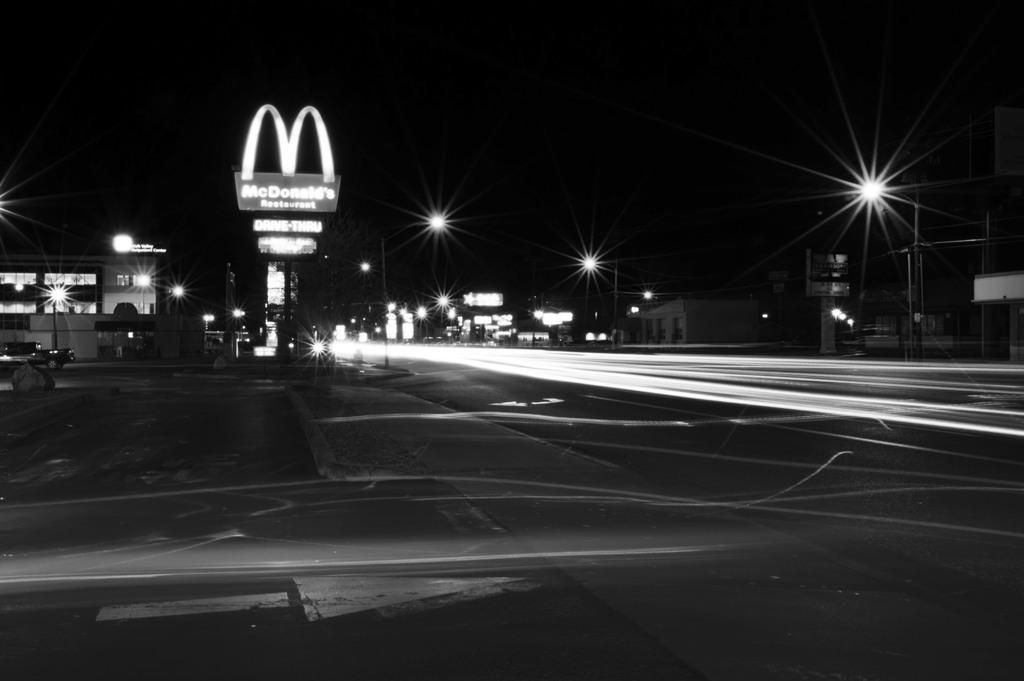Could you give a brief overview of what you see in this image? In this picture I can see few buildings, pole lights and few boards with some text and I can see dark background and a vehicle on the road. 